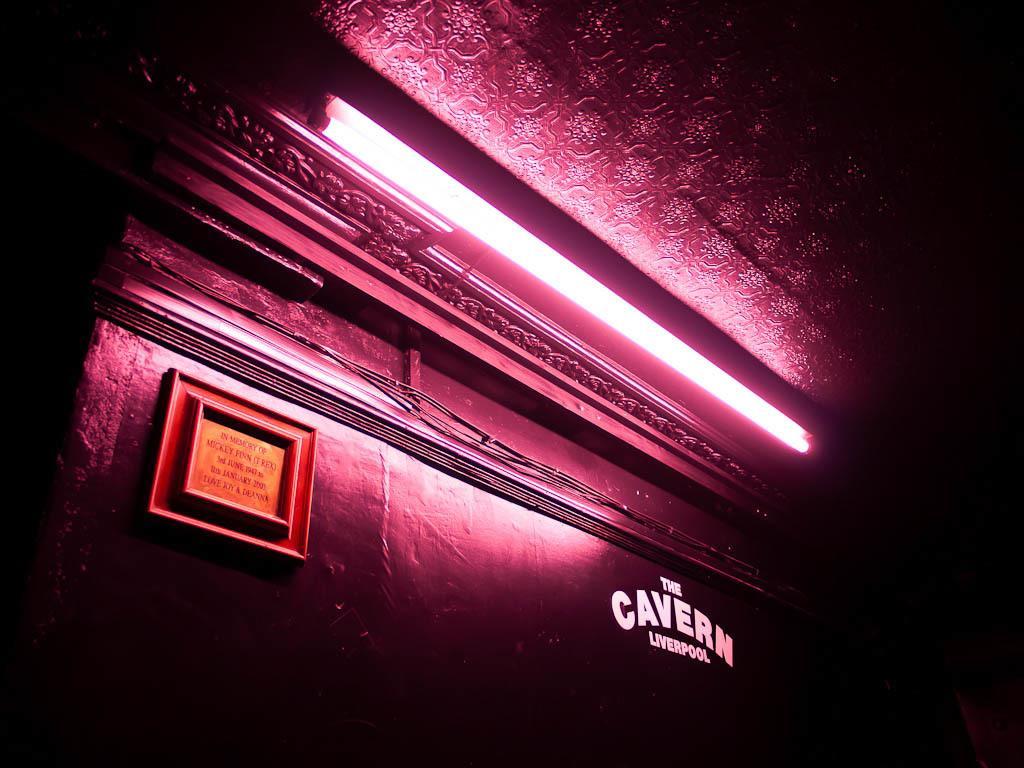Describe this image in one or two sentences. This image consists of a building. In the front, we can see a wall in pink color. And there is a light. And we can see a board and text. 